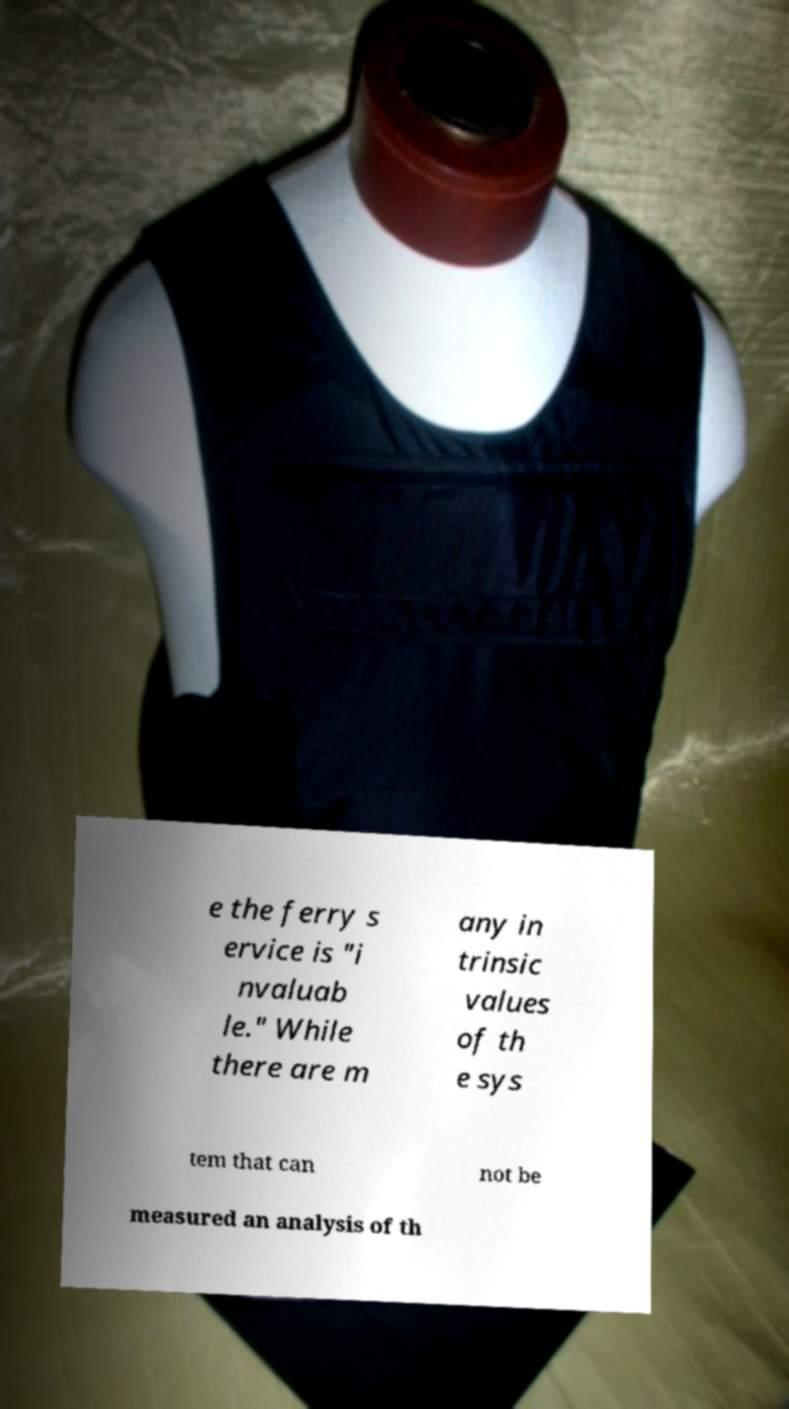Can you read and provide the text displayed in the image?This photo seems to have some interesting text. Can you extract and type it out for me? e the ferry s ervice is "i nvaluab le." While there are m any in trinsic values of th e sys tem that can not be measured an analysis of th 